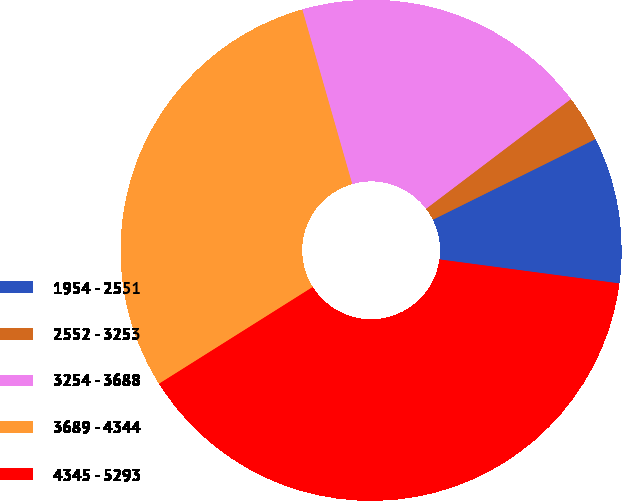Convert chart. <chart><loc_0><loc_0><loc_500><loc_500><pie_chart><fcel>1954 - 2551<fcel>2552 - 3253<fcel>3254 - 3688<fcel>3689 - 4344<fcel>4345 - 5293<nl><fcel>9.44%<fcel>2.99%<fcel>19.12%<fcel>29.51%<fcel>38.95%<nl></chart> 